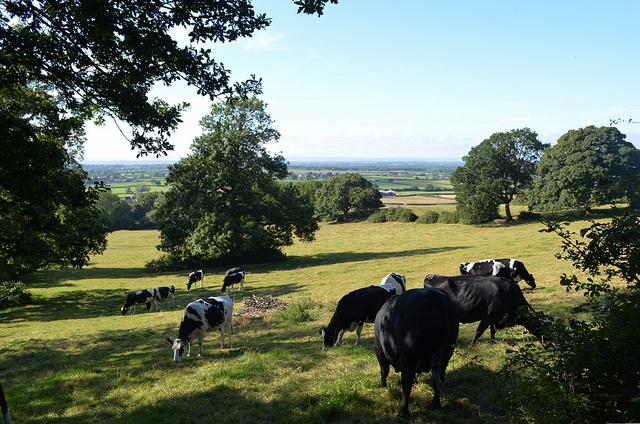Is it sunny out?
Quick response, please. Yes. Are these cows in a pasture?
Concise answer only. Yes. What animals are these?
Give a very brief answer. Cows. Is the are grassy?
Keep it brief. Yes. 